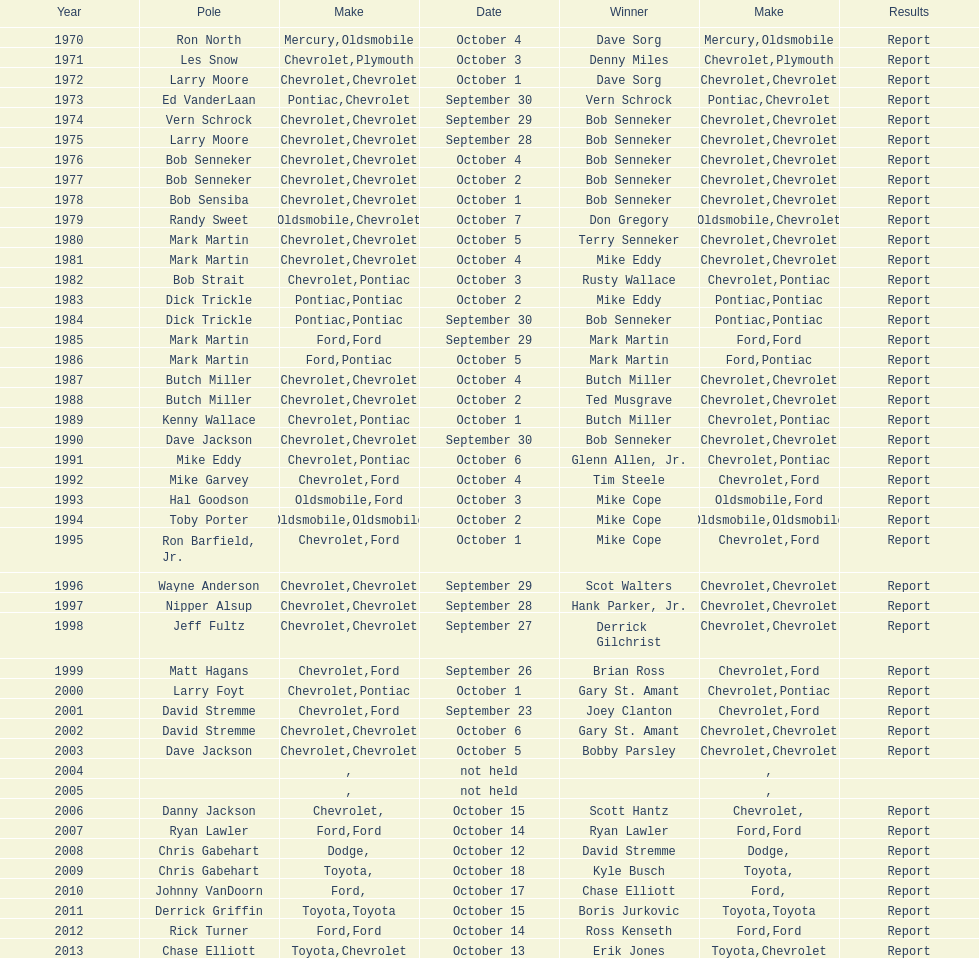Which make of car was used the least by those that won races? Toyota. 